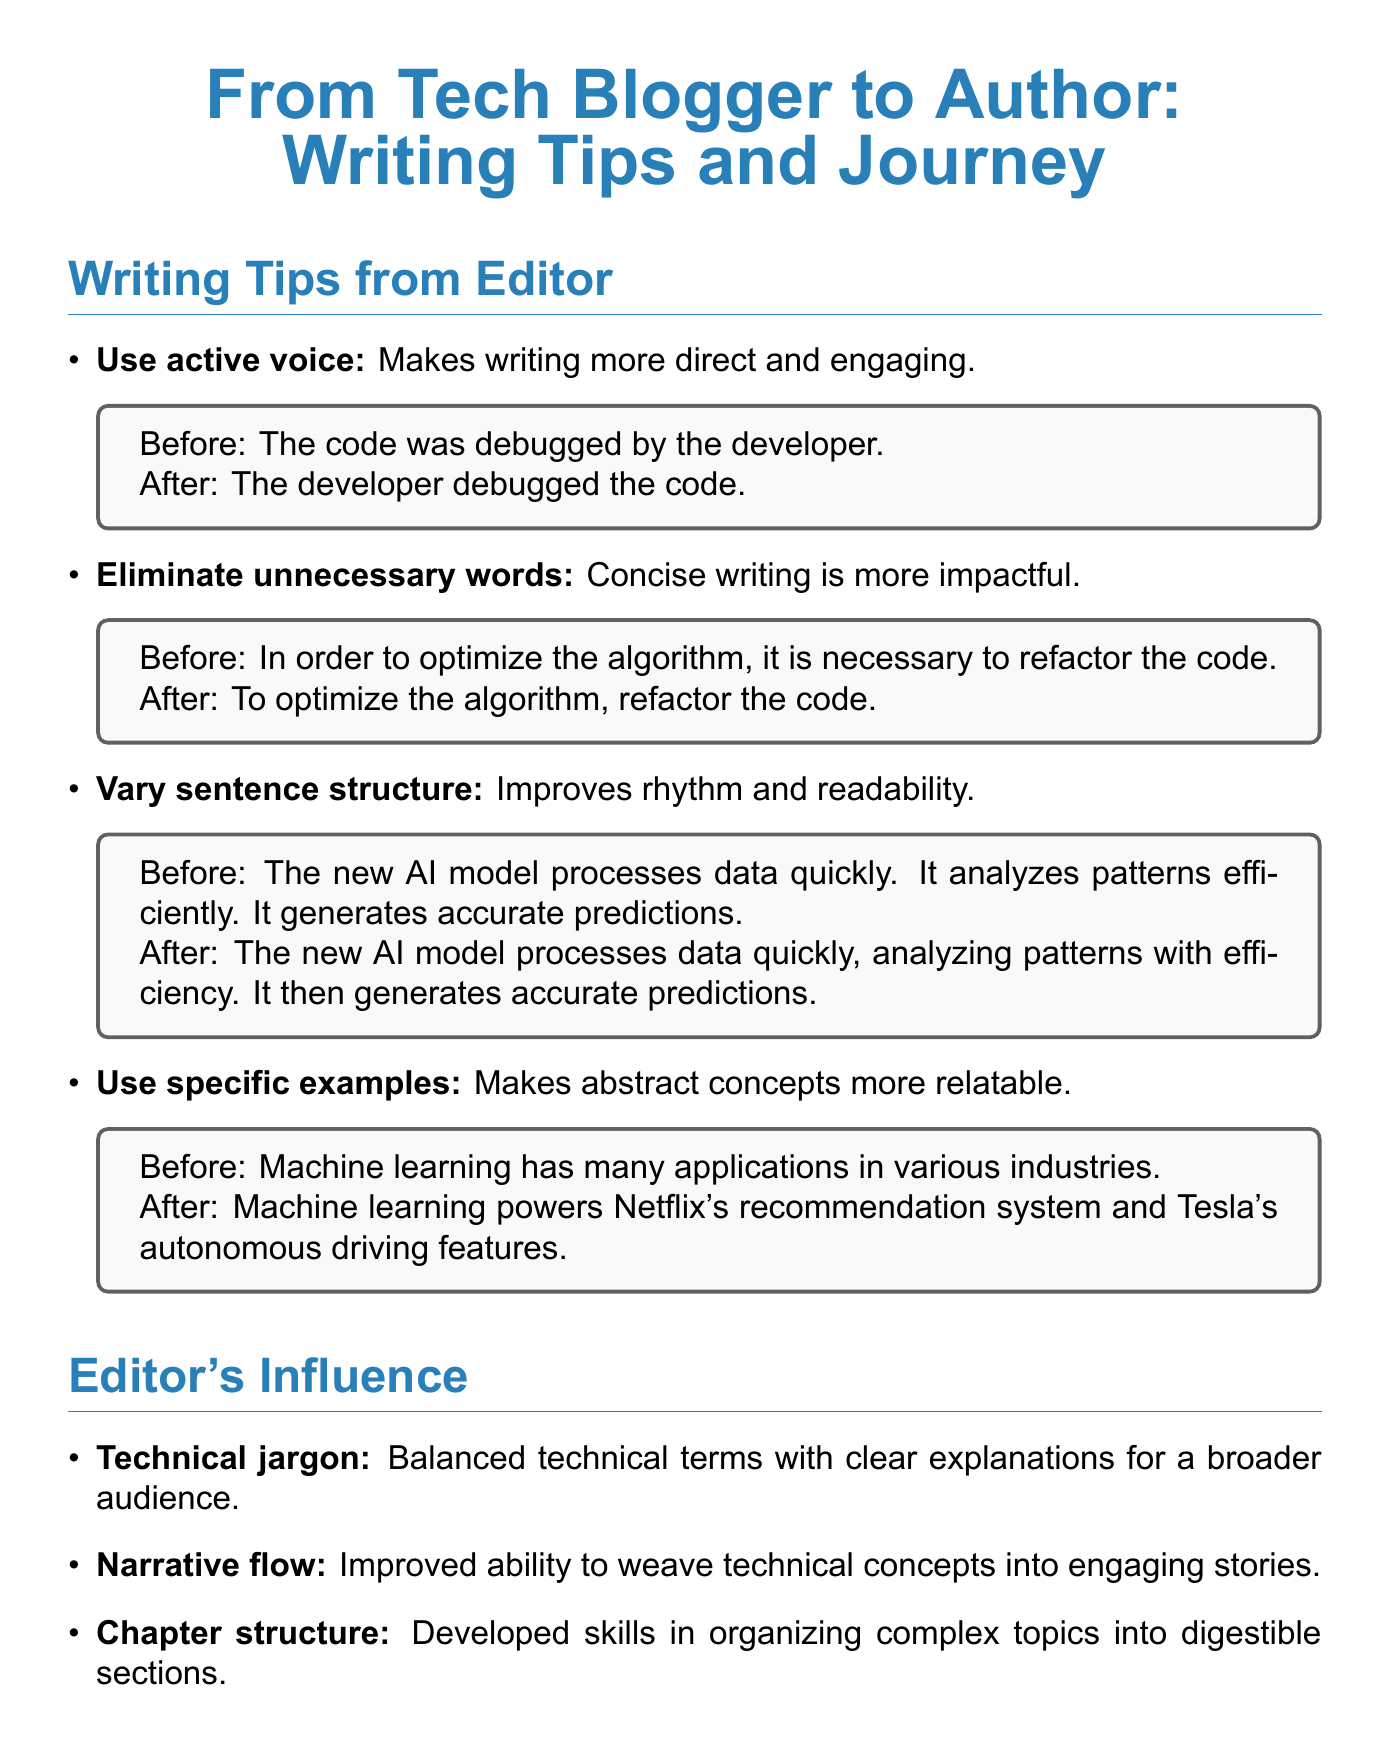What is a key writing tip mentioned? The document lists various writing tips provided by the editor, one of which is using active voice.
Answer: Use active voice What is the final product's title? The title of the final product, as mentioned in the document, is the culmination of the author's journey and writing process.
Answer: From Bits to Books: A Software Engineer's Journey into AI Who published the author’s book? The document mentions the publisher of the book, indicating who made it available to the public.
Answer: O'Reilly Media What impact did the editor have on technical jargon? The editor helped the author learn to balance complex terminology with understandable explanations for readers.
Answer: Balanced technical terms with clear explanations How many main writing tips are shared in the document? The document outlines a total number of writing tips provided by the editor, showcasing their importance.
Answer: Four What aspect of writing was improved regarding narrative flow? The document states that the author improved the ability to weave technical concepts into engaging narratives.
Answer: Improved ability to weave technical concepts into engaging stories What was the editor's feedback on the initial draft? The document specifically details the feedback received from the editor about what was needed in the initial draft.
Answer: Needed more cohesive narrative and deeper technical insights Which writing tip emphasizes readability? The tip that focuses on writing style and enhancing the flow of text through variations is emphasized in the document.
Answer: Vary sentence structure What was the initial draft type? The document describes the nature of the initial draft the author presented to the editor for review.
Answer: Tech blog posts compilation 